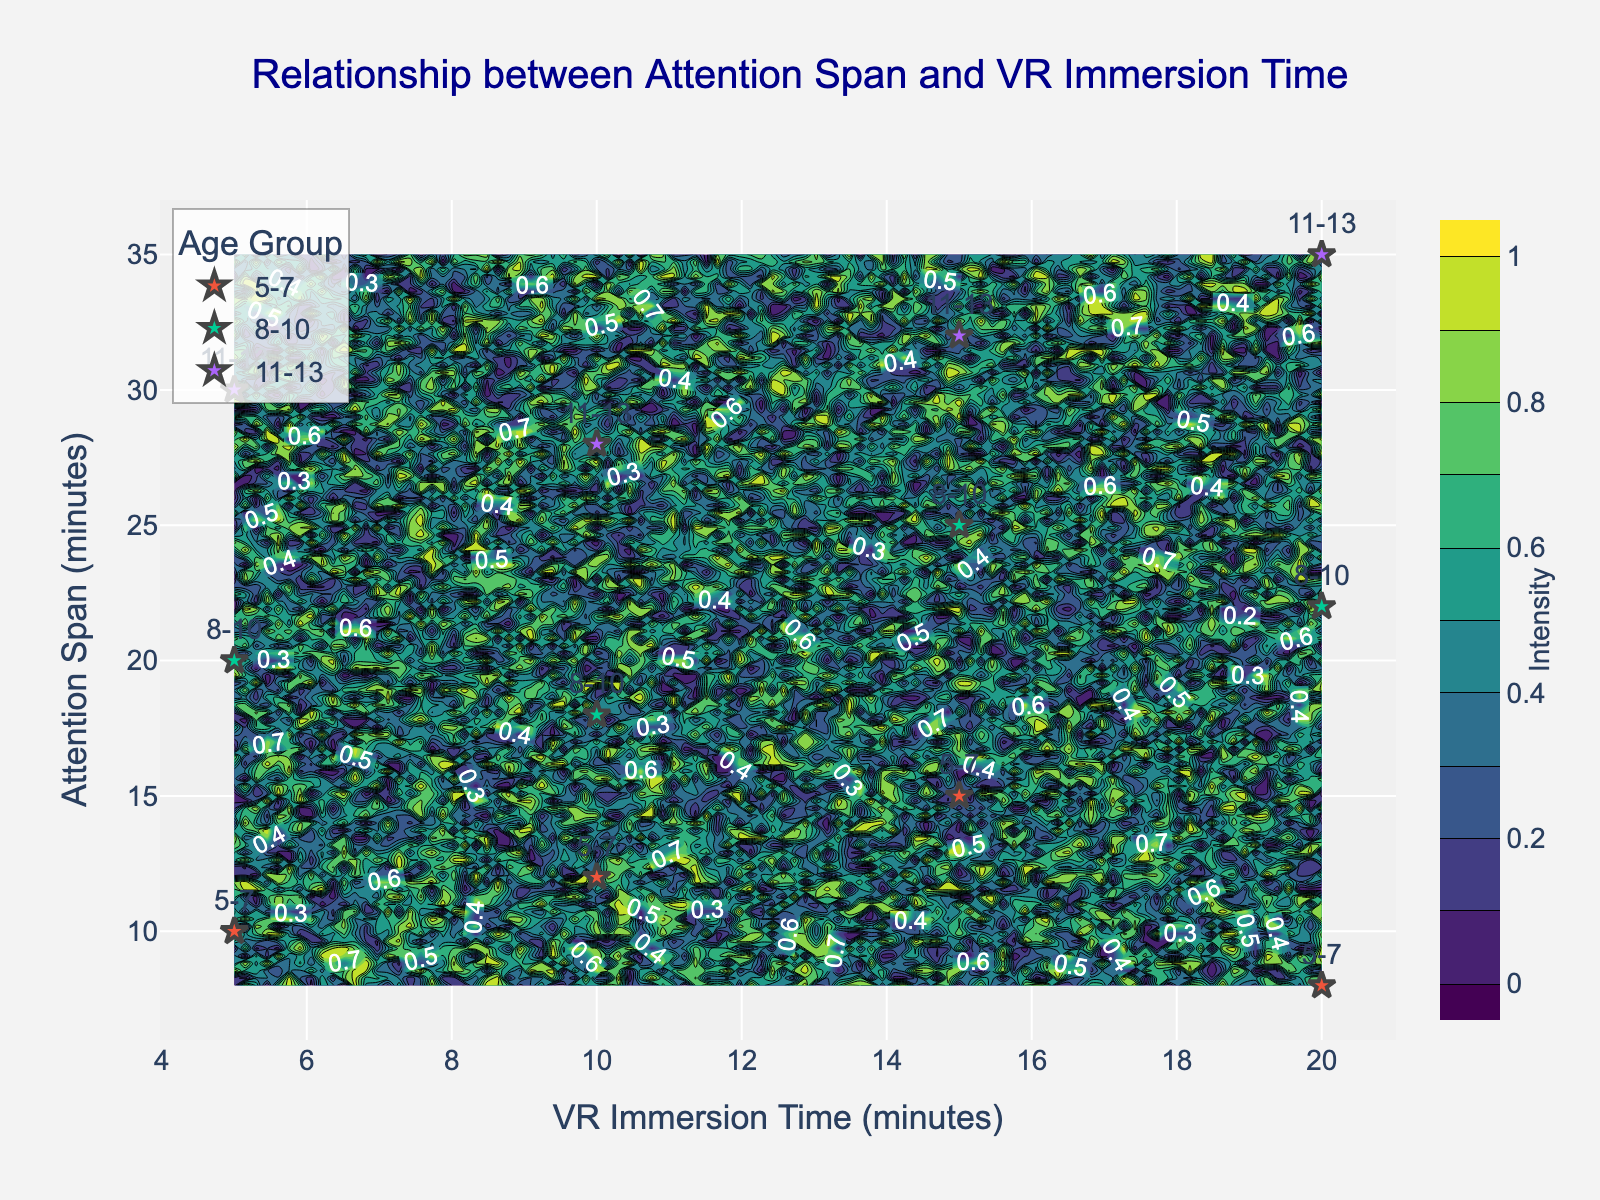What is the title of the plot? The title of the plot is displayed at the very top, centered and in dark blue color.
Answer: Relationship between Attention Span and VR Immersion Time How many age groups are represented in the plot? The legend on the right-hand side of the plot lists all age groups that are represented, which are indicated by different markers and text labels on the scatter plot.
Answer: 3 Which age group has the highest attention span for 15 minutes of VR immersion? Look for the point where VR Immersion Time is 15 minutes and compare the Attention Span across different age groups at this point.
Answer: 11-13 What is the general trend visible between attention span and VR immersion time for the 8-10 age group? Observe the data points corresponding to age group 8-10 and notice whether they increase or decrease as VR immersion time increases.
Answer: Increasing trend Which age group shows an attention span decrease at higher VR immersion times? Examine the data points of each age group and spot any decline in attention span as the VR immersion time increases.
Answer: 5-7 How does the attention span at 10 minutes of VR Immersion compare between the age groups 5-7 and 8-10? Locate the points for each age group where VR immersion time is 10 minutes and compare their attention span values.
Answer: Higher for 8-10 What is the range of attention spans observed in the plot? Look at the y-axis to determine the minimum and maximum values of attention span across all data points.
Answer: 8 to 35 minutes Which age group is consistently having the highest attention span at each VR immersion time interval? Observe the label and position of data points at each VR immersion time interval to see which age group generally has the highest attention span at each interval.
Answer: 11-13 What contour color represents the highest intensity? Refer to the color bar on the right-hand side of the plot, which shows the mapping of colors to intensity levels.
Answer: Darkest green How do the attention spans at 20 minutes of VR immersion time compare between the age groups 8-10 and 11-13? Find the points where VR immersion is 20 minutes for age groups 8-10 and 11-13 and compare their attention spans.
Answer: Higher for 11-13 